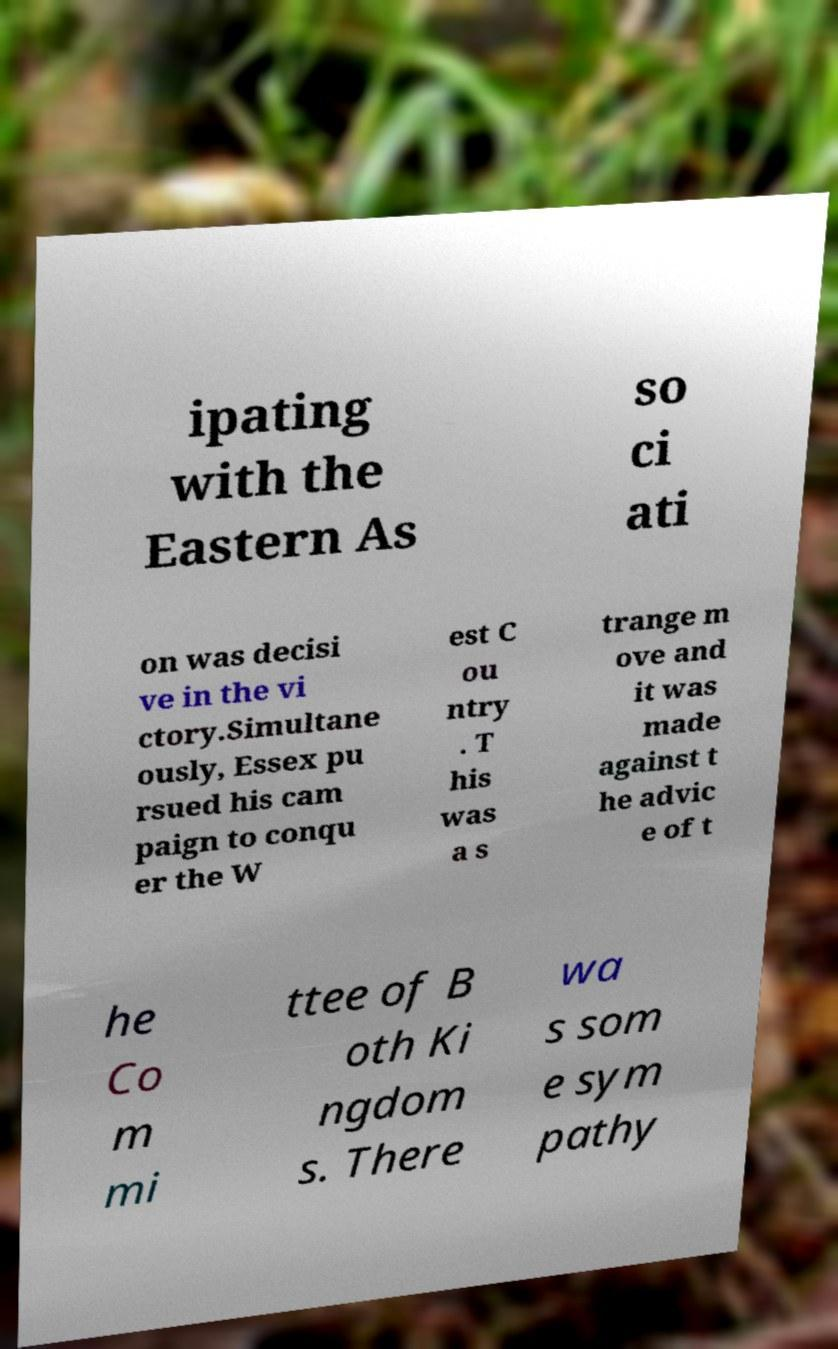Could you assist in decoding the text presented in this image and type it out clearly? ipating with the Eastern As so ci ati on was decisi ve in the vi ctory.Simultane ously, Essex pu rsued his cam paign to conqu er the W est C ou ntry . T his was a s trange m ove and it was made against t he advic e of t he Co m mi ttee of B oth Ki ngdom s. There wa s som e sym pathy 